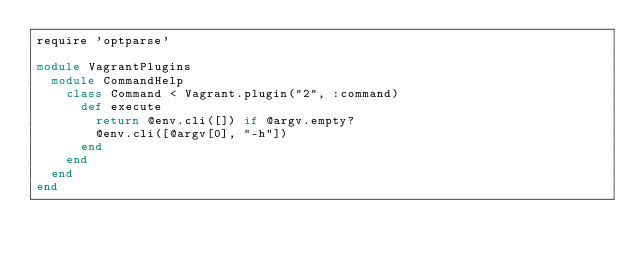<code> <loc_0><loc_0><loc_500><loc_500><_Ruby_>require 'optparse'

module VagrantPlugins
  module CommandHelp
    class Command < Vagrant.plugin("2", :command)
      def execute
        return @env.cli([]) if @argv.empty?
        @env.cli([@argv[0], "-h"])
      end
    end
  end
end
</code> 